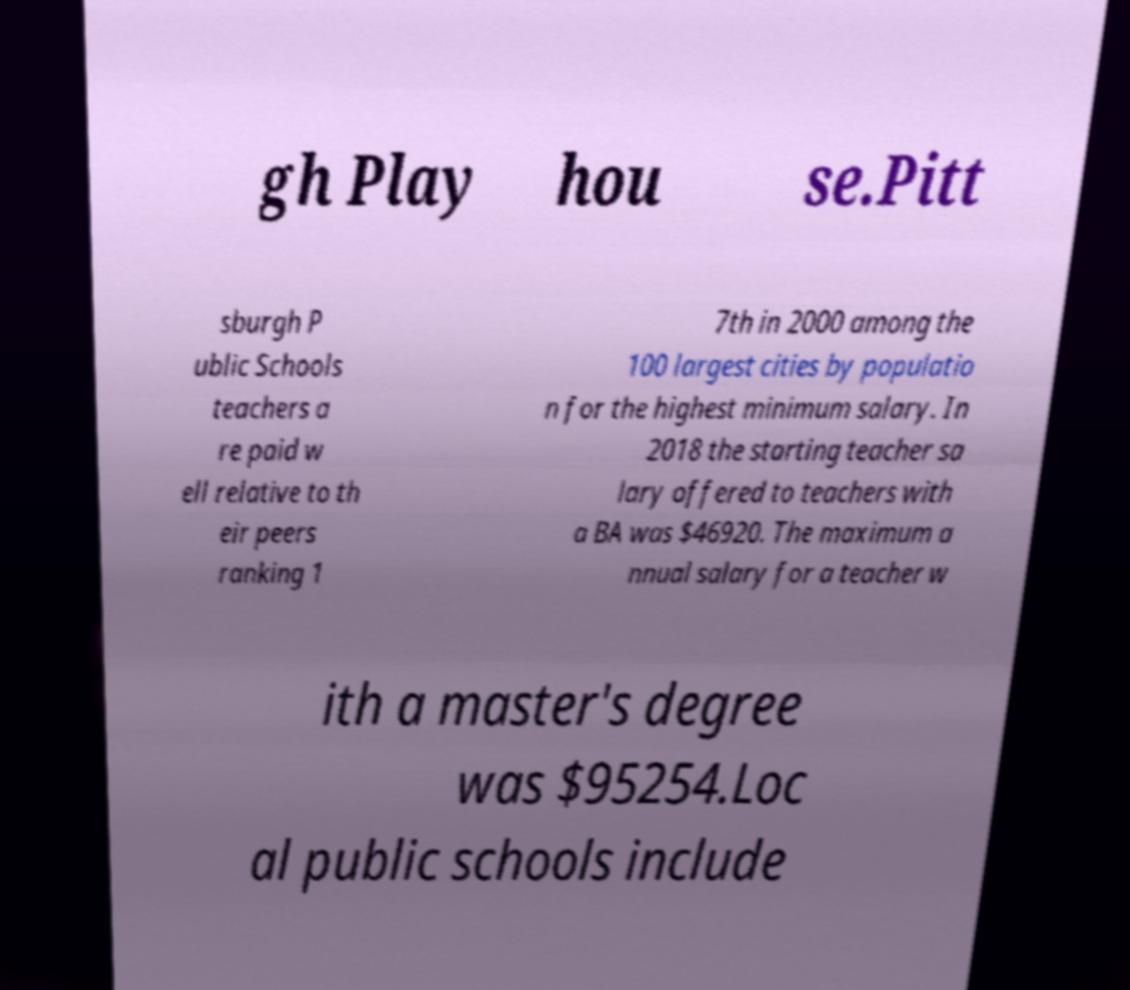I need the written content from this picture converted into text. Can you do that? gh Play hou se.Pitt sburgh P ublic Schools teachers a re paid w ell relative to th eir peers ranking 1 7th in 2000 among the 100 largest cities by populatio n for the highest minimum salary. In 2018 the starting teacher sa lary offered to teachers with a BA was $46920. The maximum a nnual salary for a teacher w ith a master's degree was $95254.Loc al public schools include 